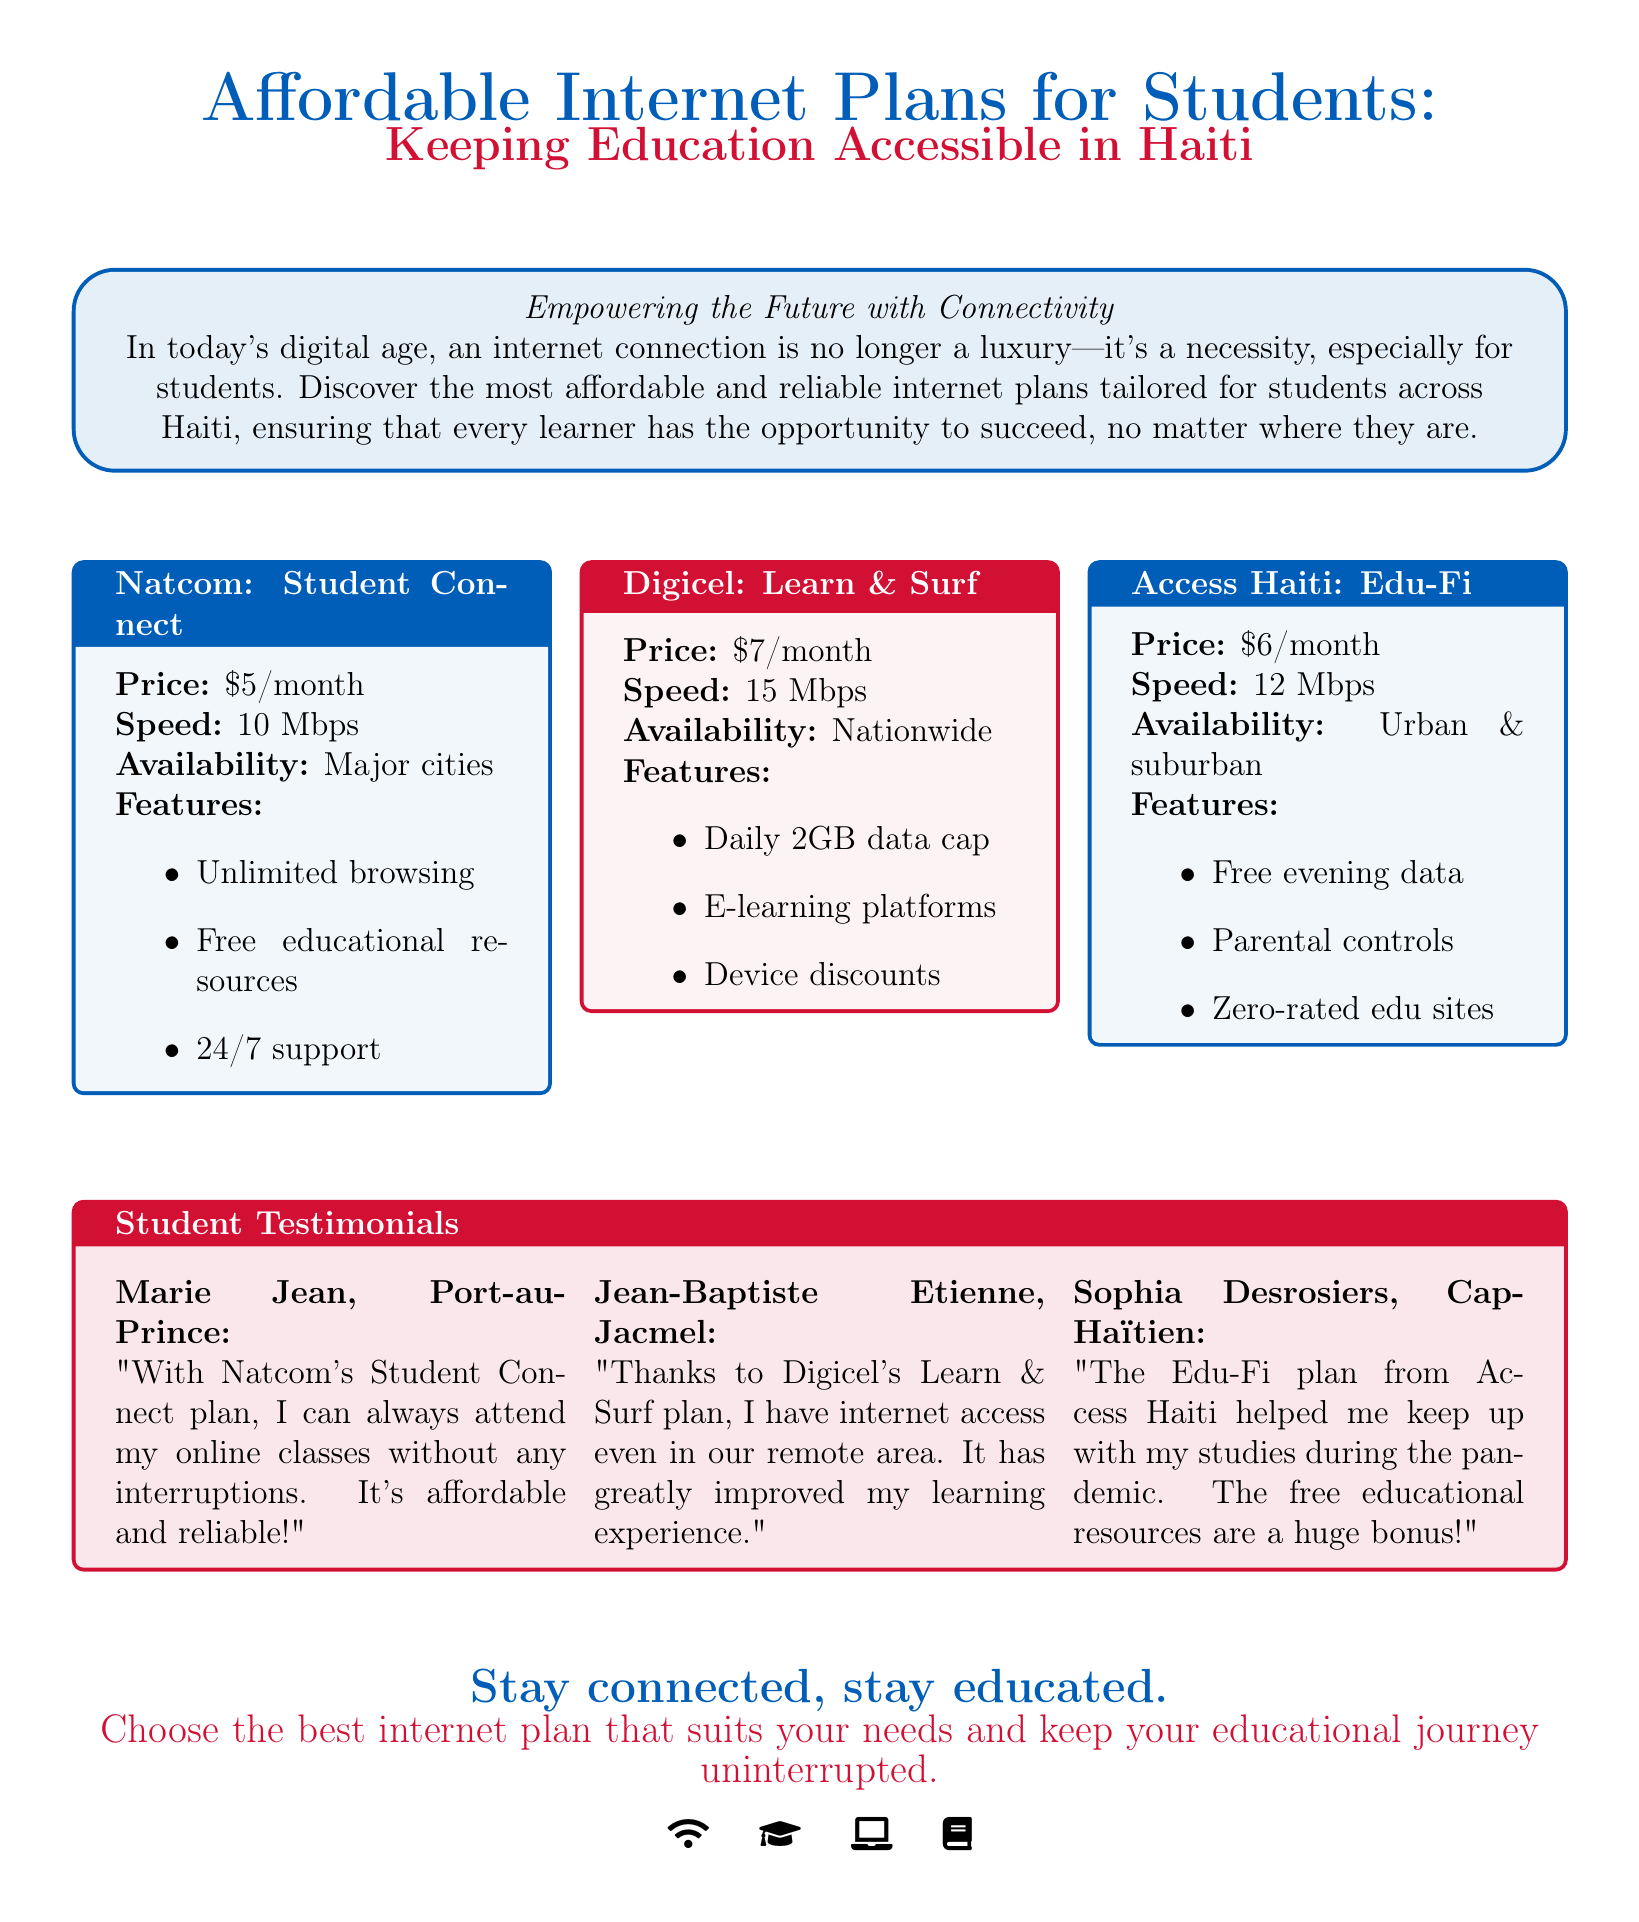What is the price of Natcom's plan? The document provides the specific price for Natcom's Student Connect plan, which is $5/month.
Answer: $5/month What is the speed of Digicel's internet plan? According to the advertisement, Digicel's Learn & Surf plan offers a speed of 15 Mbps.
Answer: 15 Mbps Which plan has a feature of free evening data? The feature of free evening data is associated with the Access Haiti: Edu-Fi plan, as indicated in the document.
Answer: Edu-Fi Who is a testimonial giver from Port-au-Prince? The advertisement mentions Marie Jean as the individual providing a testimonial from Port-au-Prince.
Answer: Marie Jean What is the monthly cost of Digicel's plan? The document specifies that the monthly cost of Digicel's Learn & Surf plan is $7/month.
Answer: $7/month How many testimonials are included in the advertisement? The advertisement includes three testimonials from students, as outlined in the document.
Answer: Three Which plan is available nationwide? The document states that Digicel's Learn & Surf plan is available nationwide.
Answer: Learn & Surf What is the customer support availability for Natcom's plan? The advertisement mentions that Natcom's plan includes 24/7 support.
Answer: 24/7 support 